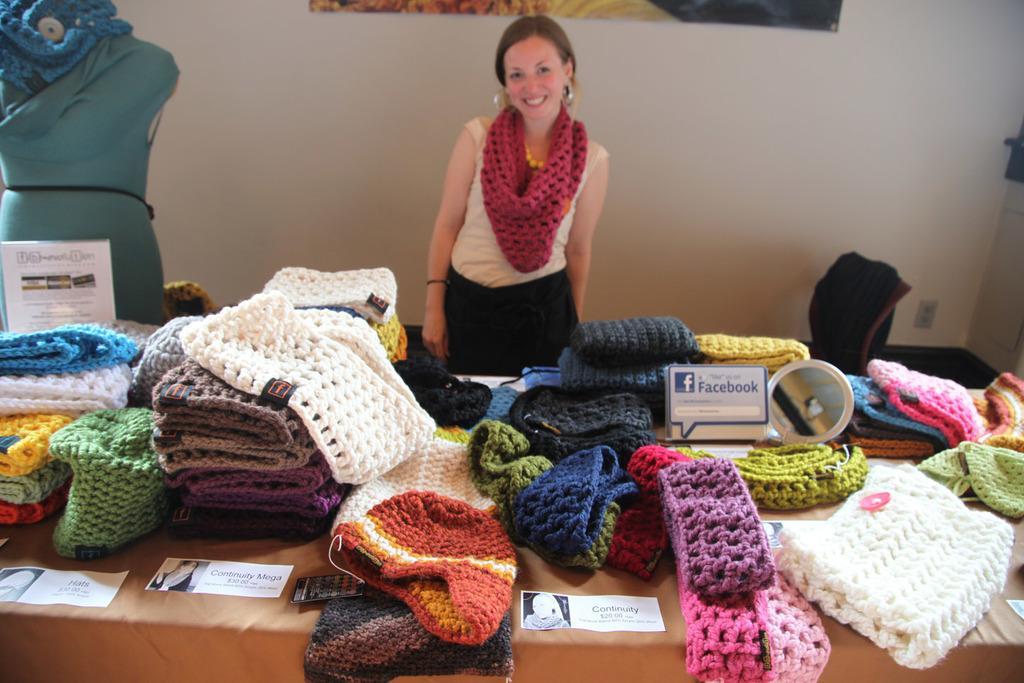Please provide a concise description of this image. In the picture there is a woman and in front of their there are many woolen clothes kept on a table and on the left side there is a mannequin and in the background there is a wall. 